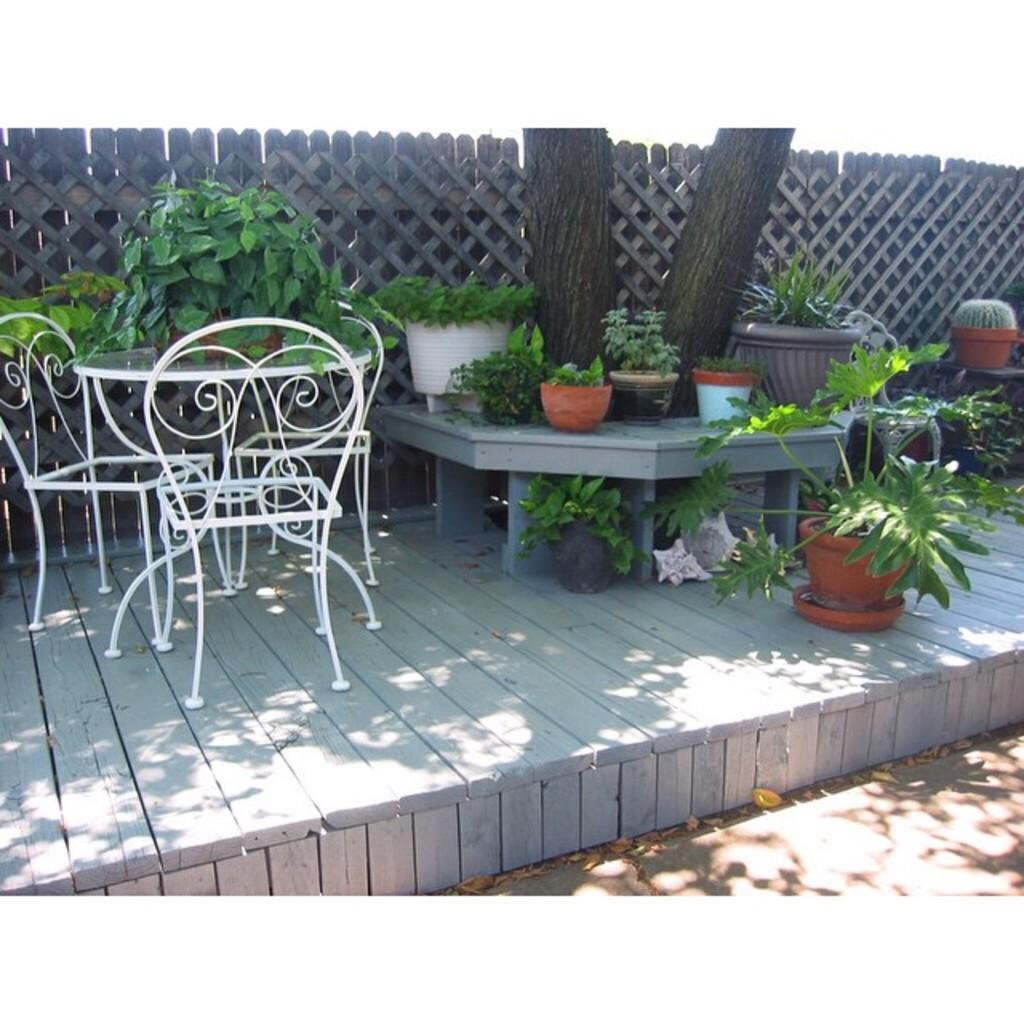Please provide a concise description of this image. In this picture we can see a table and chairs are arranged aside and some potted plants are there and one big tree back of it one wall is there this all are arranged in place 